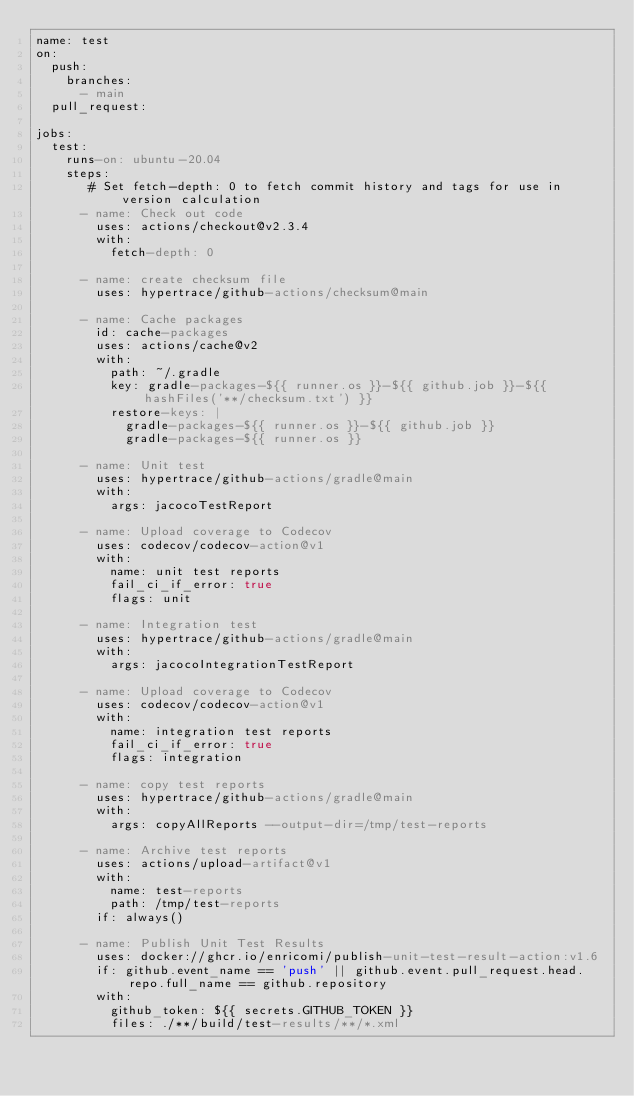Convert code to text. <code><loc_0><loc_0><loc_500><loc_500><_YAML_>name: test
on:
  push:
    branches:
      - main
  pull_request:

jobs:
  test:
    runs-on: ubuntu-20.04
    steps:
       # Set fetch-depth: 0 to fetch commit history and tags for use in version calculation
      - name: Check out code
        uses: actions/checkout@v2.3.4
        with:
          fetch-depth: 0
      
      - name: create checksum file
        uses: hypertrace/github-actions/checksum@main

      - name: Cache packages
        id: cache-packages
        uses: actions/cache@v2
        with:
          path: ~/.gradle
          key: gradle-packages-${{ runner.os }}-${{ github.job }}-${{ hashFiles('**/checksum.txt') }}
          restore-keys: |
            gradle-packages-${{ runner.os }}-${{ github.job }}
            gradle-packages-${{ runner.os }}

      - name: Unit test
        uses: hypertrace/github-actions/gradle@main
        with: 
          args: jacocoTestReport

      - name: Upload coverage to Codecov
        uses: codecov/codecov-action@v1
        with:
          name: unit test reports
          fail_ci_if_error: true
          flags: unit
  
      - name: Integration test
        uses: hypertrace/github-actions/gradle@main
        with: 
          args: jacocoIntegrationTestReport

      - name: Upload coverage to Codecov
        uses: codecov/codecov-action@v1
        with:
          name: integration test reports
          fail_ci_if_error: true
          flags: integration

      - name: copy test reports
        uses: hypertrace/github-actions/gradle@main
        with: 
          args: copyAllReports --output-dir=/tmp/test-reports

      - name: Archive test reports
        uses: actions/upload-artifact@v1
        with:
          name: test-reports
          path: /tmp/test-reports
        if: always()
     
      - name: Publish Unit Test Results
        uses: docker://ghcr.io/enricomi/publish-unit-test-result-action:v1.6
        if: github.event_name == 'push' || github.event.pull_request.head.repo.full_name == github.repository
        with:
          github_token: ${{ secrets.GITHUB_TOKEN }}
          files: ./**/build/test-results/**/*.xml
</code> 